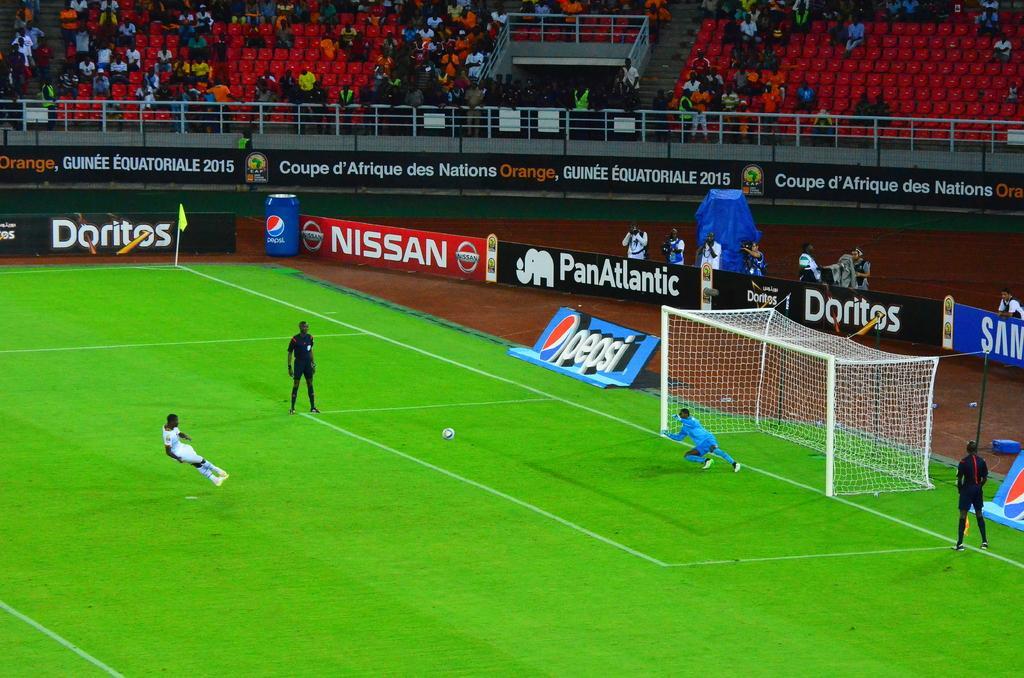How would you summarize this image in a sentence or two? In this picture we can see the view of the football ground. In the front there are some players playing the football game. Behind there is white goal post. In the background we can see some audience members sitting on the red chairs.  